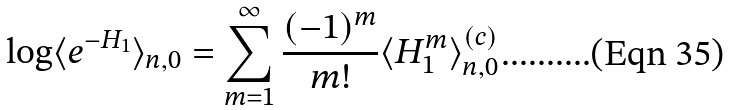<formula> <loc_0><loc_0><loc_500><loc_500>\log \langle e ^ { - H _ { 1 } } \rangle _ { n , 0 } = \sum _ { m = 1 } ^ { \infty } \frac { ( - 1 ) ^ { m } } { m ! } \langle H _ { 1 } ^ { m } \rangle _ { n , 0 } ^ { ( c ) }</formula> 